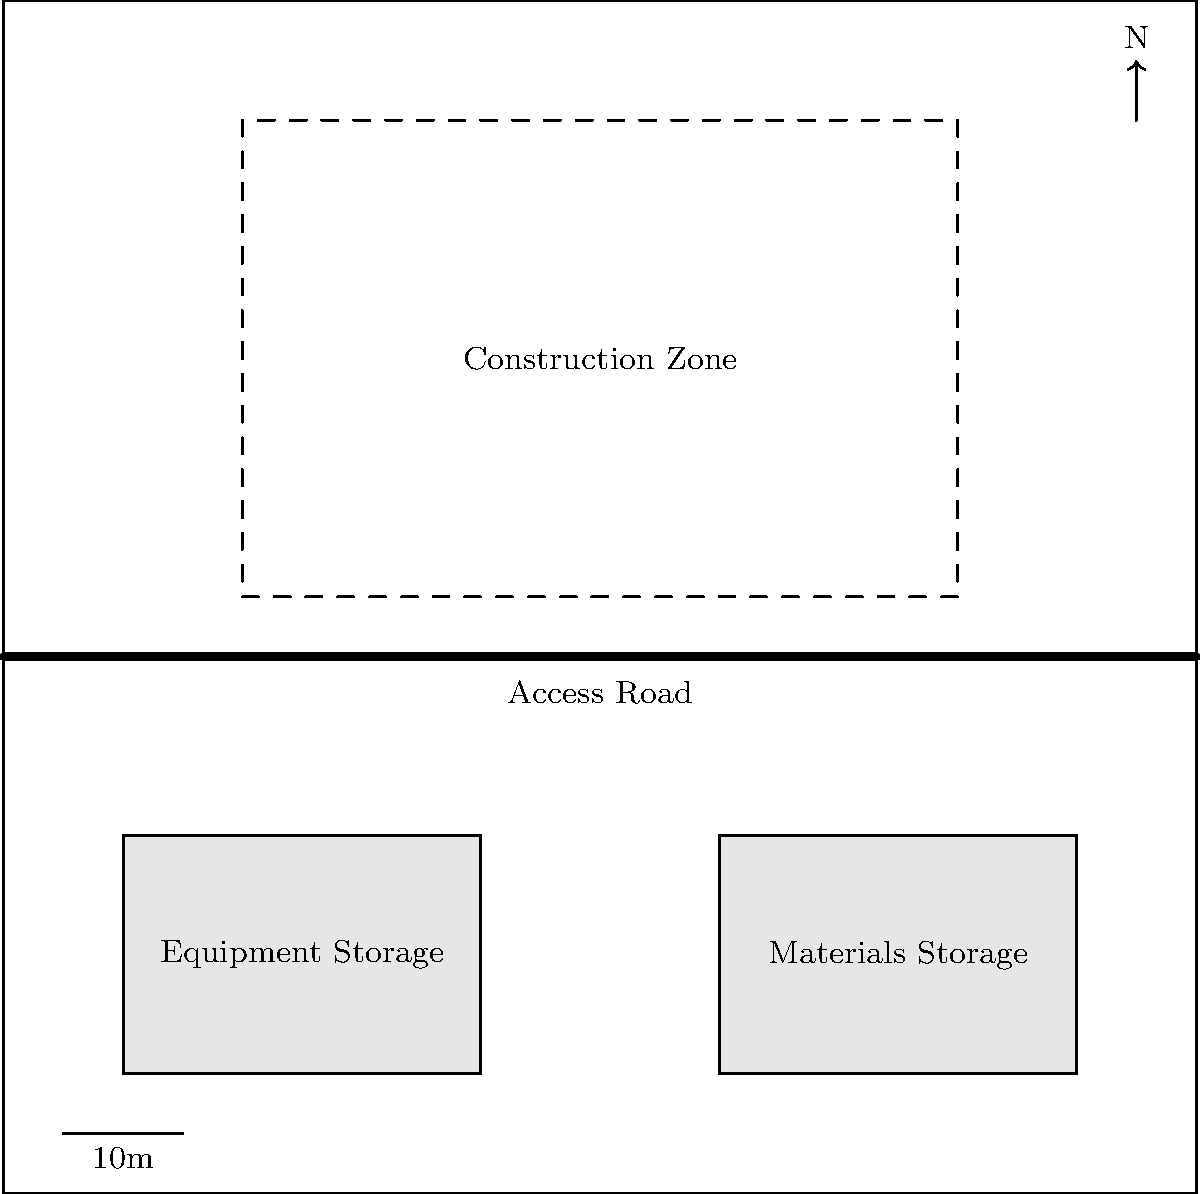Based on the site logistics plan shown, what is the most efficient path for transporting materials from the storage area to the construction zone while minimizing interference with equipment movement? To determine the most efficient path for transporting materials, we need to consider several factors:

1. Location of materials storage: The materials storage area is located in the southeast corner of the site (bottom right).

2. Location of construction zone: The construction zone is in the northern half of the site.

3. Access road: There is an access road running east-west across the middle of the site.

4. Equipment storage: The equipment storage area is in the southwest corner (bottom left).

5. Minimizing interference: We need to avoid crossing the equipment storage area and minimize potential conflicts with equipment movement.

Considering these factors, the most efficient path would be:

a) Start from the materials storage area.
b) Move north to the access road.
c) Travel west along the access road.
d) Turn north into the construction zone at an appropriate point.

This path utilizes the existing access road, which is likely designed for material transport. It also avoids crossing the equipment storage area, minimizing potential conflicts with equipment movement.

By using the access road, we ensure a clear and direct route that can accommodate larger vehicles or material loads. This path also provides flexibility, allowing entry into the construction zone at multiple points depending on the specific area where materials are needed.
Answer: Materials storage → Access road → Construction zone 